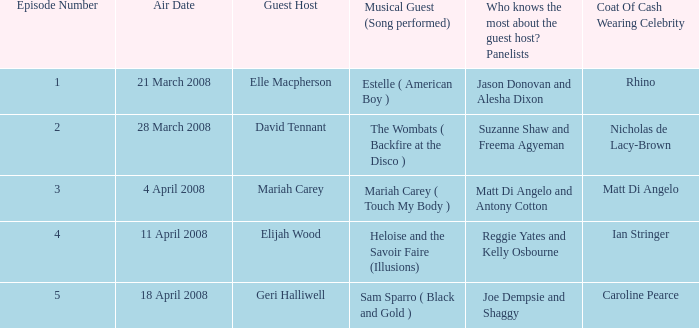With panelists matt di angelo and antony cotton, what's the count of celebrities sporting a coat of cash? 1.0. Help me parse the entirety of this table. {'header': ['Episode Number', 'Air Date', 'Guest Host', 'Musical Guest (Song performed)', 'Who knows the most about the guest host? Panelists', 'Coat Of Cash Wearing Celebrity'], 'rows': [['1', '21 March 2008', 'Elle Macpherson', 'Estelle ( American Boy )', 'Jason Donovan and Alesha Dixon', 'Rhino'], ['2', '28 March 2008', 'David Tennant', 'The Wombats ( Backfire at the Disco )', 'Suzanne Shaw and Freema Agyeman', 'Nicholas de Lacy-Brown'], ['3', '4 April 2008', 'Mariah Carey', 'Mariah Carey ( Touch My Body )', 'Matt Di Angelo and Antony Cotton', 'Matt Di Angelo'], ['4', '11 April 2008', 'Elijah Wood', 'Heloise and the Savoir Faire (Illusions)', 'Reggie Yates and Kelly Osbourne', 'Ian Stringer'], ['5', '18 April 2008', 'Geri Halliwell', 'Sam Sparro ( Black and Gold )', 'Joe Dempsie and Shaggy', 'Caroline Pearce']]} 